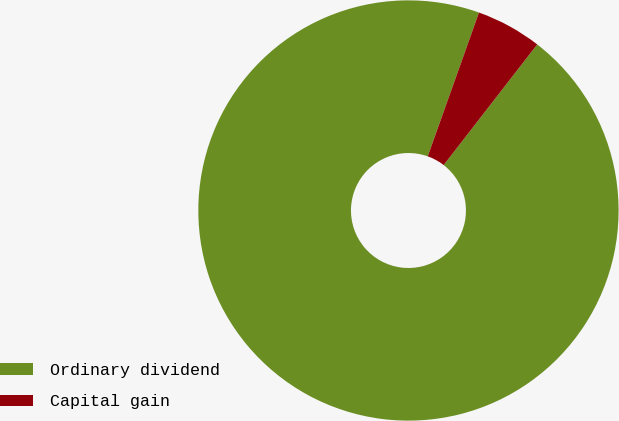<chart> <loc_0><loc_0><loc_500><loc_500><pie_chart><fcel>Ordinary dividend<fcel>Capital gain<nl><fcel>94.95%<fcel>5.05%<nl></chart> 